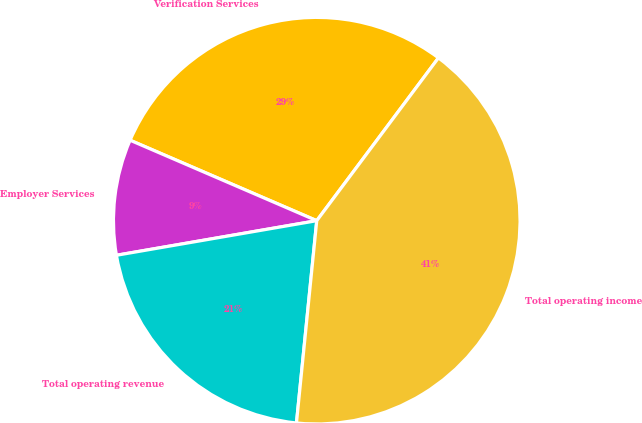<chart> <loc_0><loc_0><loc_500><loc_500><pie_chart><fcel>Verification Services<fcel>Employer Services<fcel>Total operating revenue<fcel>Total operating income<nl><fcel>28.74%<fcel>9.2%<fcel>20.69%<fcel>41.38%<nl></chart> 